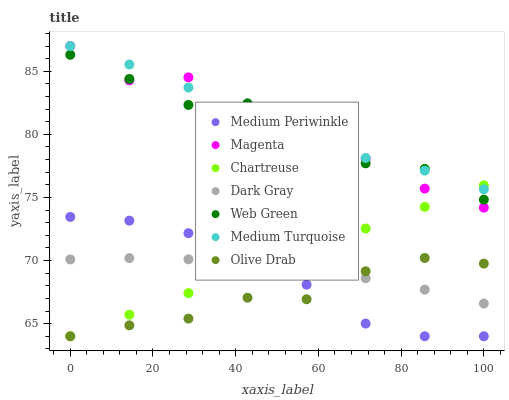Does Olive Drab have the minimum area under the curve?
Answer yes or no. Yes. Does Medium Turquoise have the maximum area under the curve?
Answer yes or no. Yes. Does Web Green have the minimum area under the curve?
Answer yes or no. No. Does Web Green have the maximum area under the curve?
Answer yes or no. No. Is Chartreuse the smoothest?
Answer yes or no. Yes. Is Magenta the roughest?
Answer yes or no. Yes. Is Web Green the smoothest?
Answer yes or no. No. Is Web Green the roughest?
Answer yes or no. No. Does Medium Periwinkle have the lowest value?
Answer yes or no. Yes. Does Web Green have the lowest value?
Answer yes or no. No. Does Magenta have the highest value?
Answer yes or no. Yes. Does Web Green have the highest value?
Answer yes or no. No. Is Dark Gray less than Magenta?
Answer yes or no. Yes. Is Medium Turquoise greater than Dark Gray?
Answer yes or no. Yes. Does Medium Turquoise intersect Web Green?
Answer yes or no. Yes. Is Medium Turquoise less than Web Green?
Answer yes or no. No. Is Medium Turquoise greater than Web Green?
Answer yes or no. No. Does Dark Gray intersect Magenta?
Answer yes or no. No. 